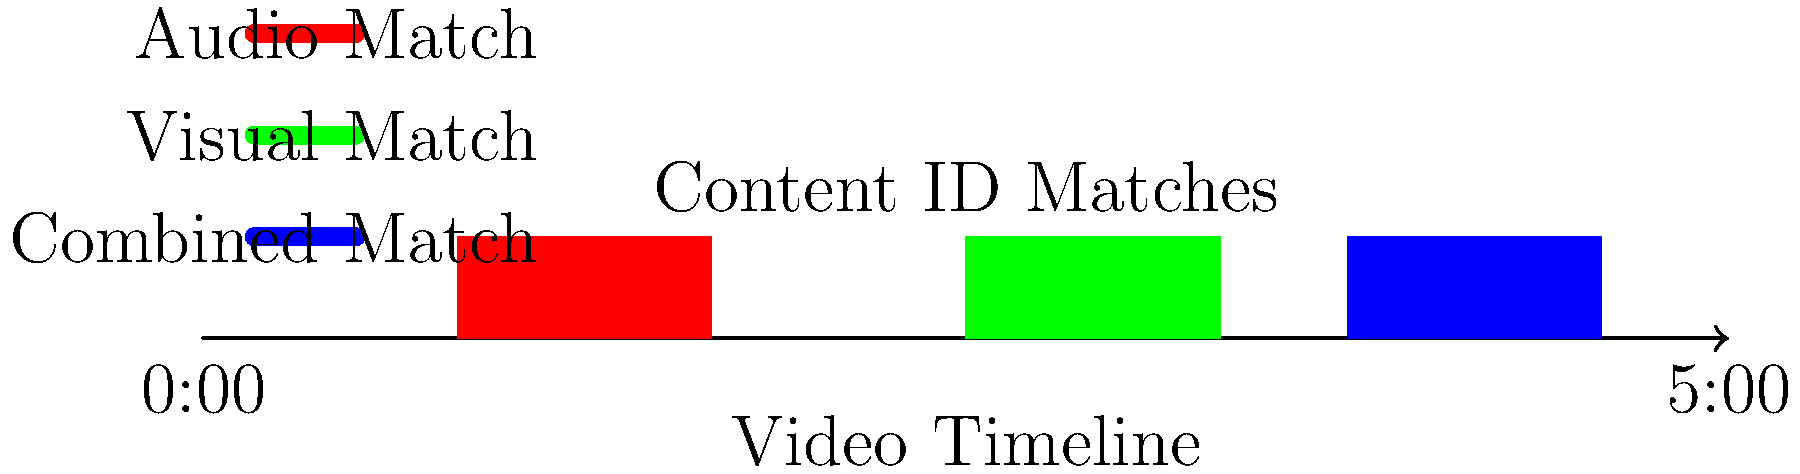Based on the content ID match visualization for a 5-minute YouTube video, what is the total duration of content that has been flagged for potential copyright infringement? To determine the total duration of flagged content, we need to follow these steps:

1. Identify the flagged segments:
   - Red segment (audio match): From 0:50 to 1:40
   - Green segment (visual match): From 2:30 to 3:20
   - Blue segment (combined match): From 3:45 to 4:35

2. Calculate the duration of each segment:
   - Red segment: 1:40 - 0:50 = 50 seconds
   - Green segment: 3:20 - 2:30 = 50 seconds
   - Blue segment: 4:35 - 3:45 = 50 seconds

3. Sum up the durations:
   50 + 50 + 50 = 150 seconds

4. Convert to minutes:
   150 seconds = 2 minutes 30 seconds

Therefore, the total duration of content flagged for potential copyright infringement is 2 minutes and 30 seconds.
Answer: 2 minutes 30 seconds 